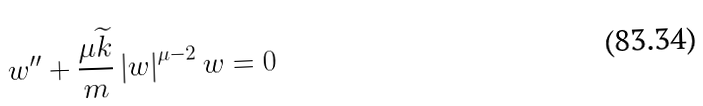Convert formula to latex. <formula><loc_0><loc_0><loc_500><loc_500>w ^ { \prime \prime } + \frac { \mu \widetilde { k } } { m } \left | w \right | ^ { \mu - 2 } w = 0</formula> 